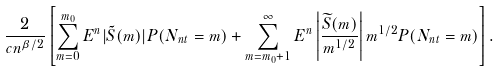<formula> <loc_0><loc_0><loc_500><loc_500>\frac { 2 } { c n ^ { \beta / 2 } } \left [ \sum _ { m = 0 } ^ { m _ { 0 } } E ^ { n } | \tilde { S } ( m ) | P ( N _ { n t } = m ) + \sum _ { m = m _ { 0 } + 1 } ^ { \infty } E ^ { n } \left | \frac { \widetilde { S } ( m ) } { m ^ { 1 / 2 } } \right | m ^ { 1 / 2 } P ( N _ { n t } = m ) \right ] .</formula> 